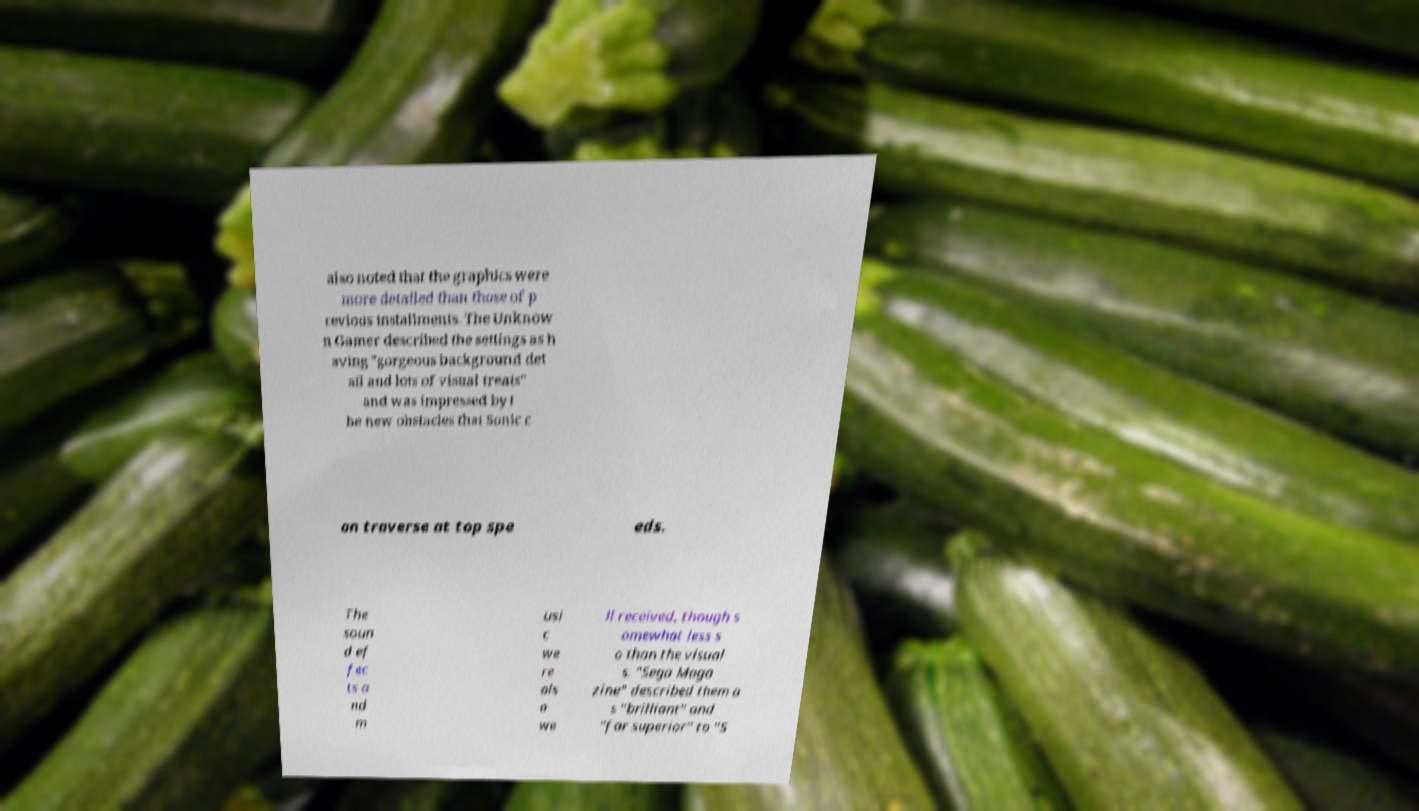Could you assist in decoding the text presented in this image and type it out clearly? also noted that the graphics were more detailed than those of p revious installments. The Unknow n Gamer described the settings as h aving "gorgeous background det ail and lots of visual treats" and was impressed by t he new obstacles that Sonic c an traverse at top spe eds. The soun d ef fec ts a nd m usi c we re als o we ll received, though s omewhat less s o than the visual s. "Sega Maga zine" described them a s "brilliant" and "far superior" to "S 